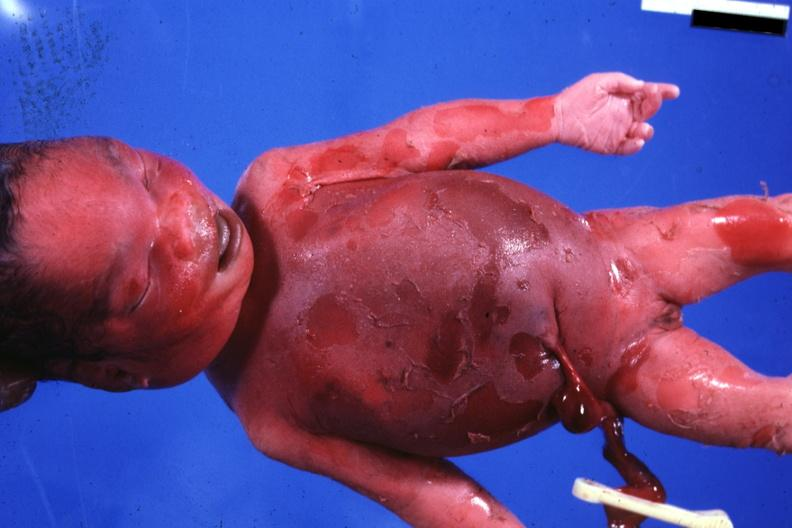what is present?
Answer the question using a single word or phrase. Stillborn macerated 